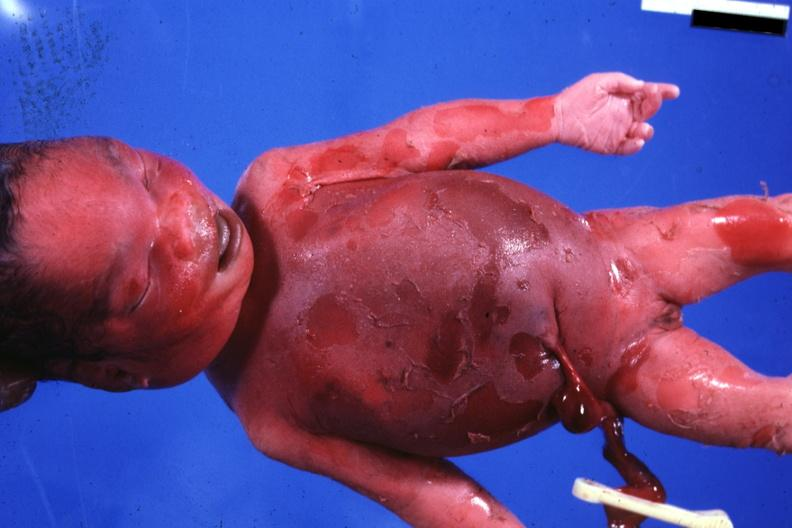what is present?
Answer the question using a single word or phrase. Stillborn macerated 